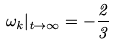<formula> <loc_0><loc_0><loc_500><loc_500>\omega _ { k } | _ { t \rightarrow \infty } = - \frac { 2 } { 3 }</formula> 